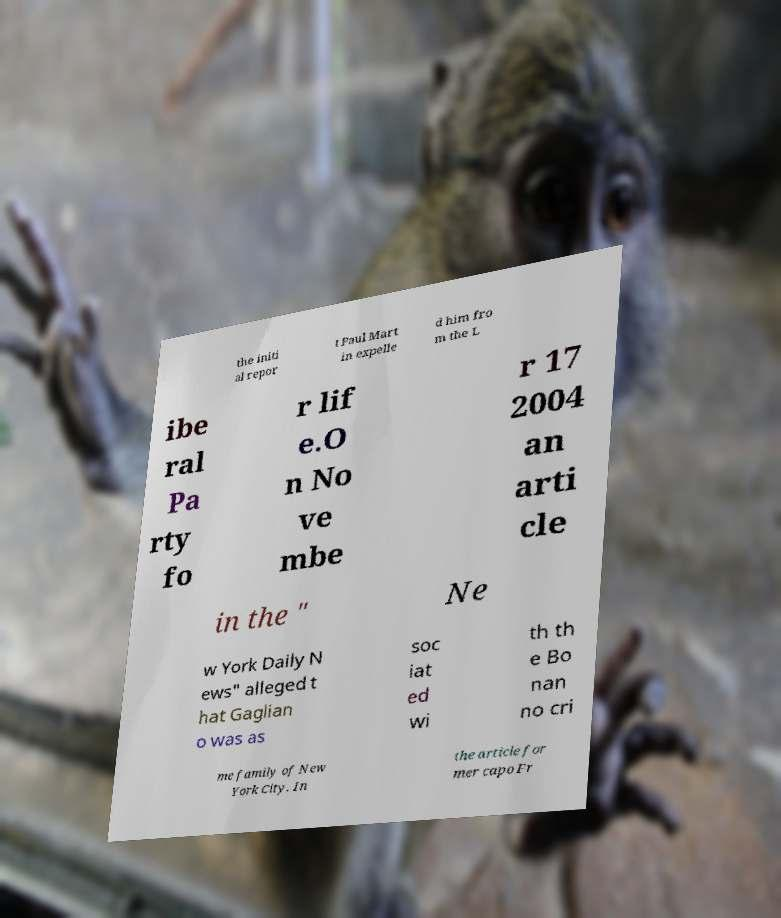Please read and relay the text visible in this image. What does it say? the initi al repor t Paul Mart in expelle d him fro m the L ibe ral Pa rty fo r lif e.O n No ve mbe r 17 2004 an arti cle in the " Ne w York Daily N ews" alleged t hat Gaglian o was as soc iat ed wi th th e Bo nan no cri me family of New York City. In the article for mer capo Fr 